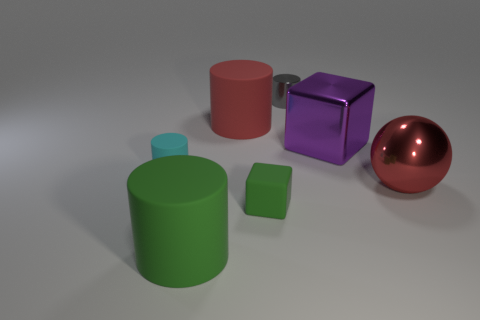Subtract all green cylinders. How many cylinders are left? 3 Subtract all gray cylinders. How many cylinders are left? 3 Add 3 small green objects. How many objects exist? 10 Subtract all cubes. How many objects are left? 5 Subtract all small cylinders. Subtract all small cyan matte cubes. How many objects are left? 5 Add 2 big metallic balls. How many big metallic balls are left? 3 Add 3 big red rubber objects. How many big red rubber objects exist? 4 Subtract 0 blue cubes. How many objects are left? 7 Subtract all purple spheres. Subtract all yellow cylinders. How many spheres are left? 1 Subtract all green cylinders. How many purple cubes are left? 1 